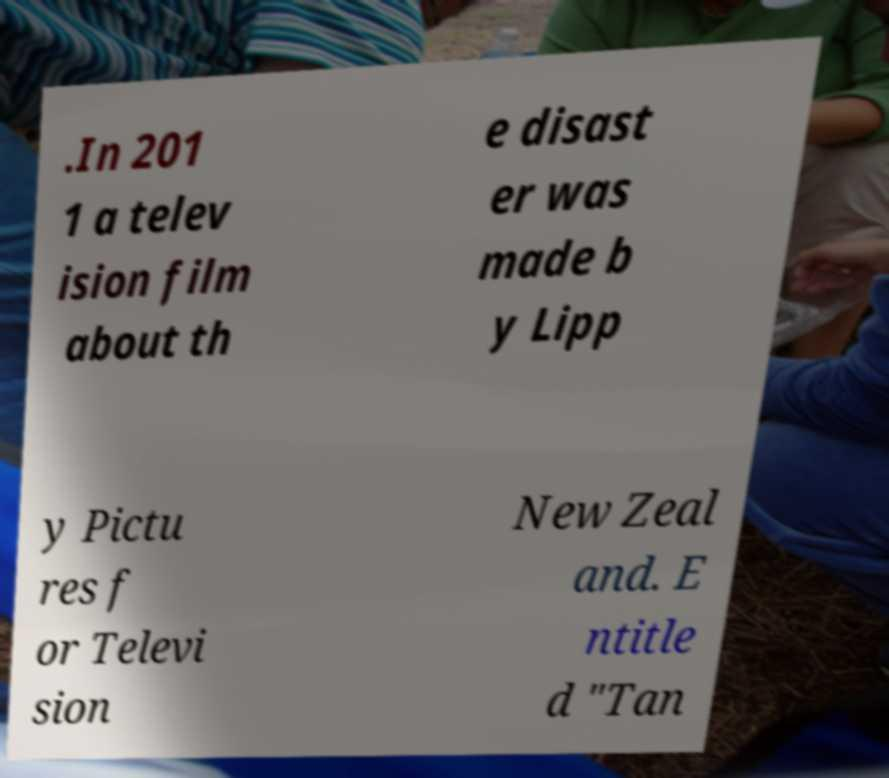I need the written content from this picture converted into text. Can you do that? .In 201 1 a telev ision film about th e disast er was made b y Lipp y Pictu res f or Televi sion New Zeal and. E ntitle d "Tan 